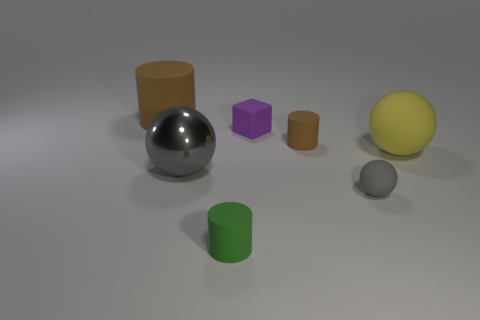Add 1 small cylinders. How many objects exist? 8 Subtract all cubes. How many objects are left? 6 Subtract 0 purple cylinders. How many objects are left? 7 Subtract all big things. Subtract all tiny gray matte balls. How many objects are left? 3 Add 6 brown things. How many brown things are left? 8 Add 4 balls. How many balls exist? 7 